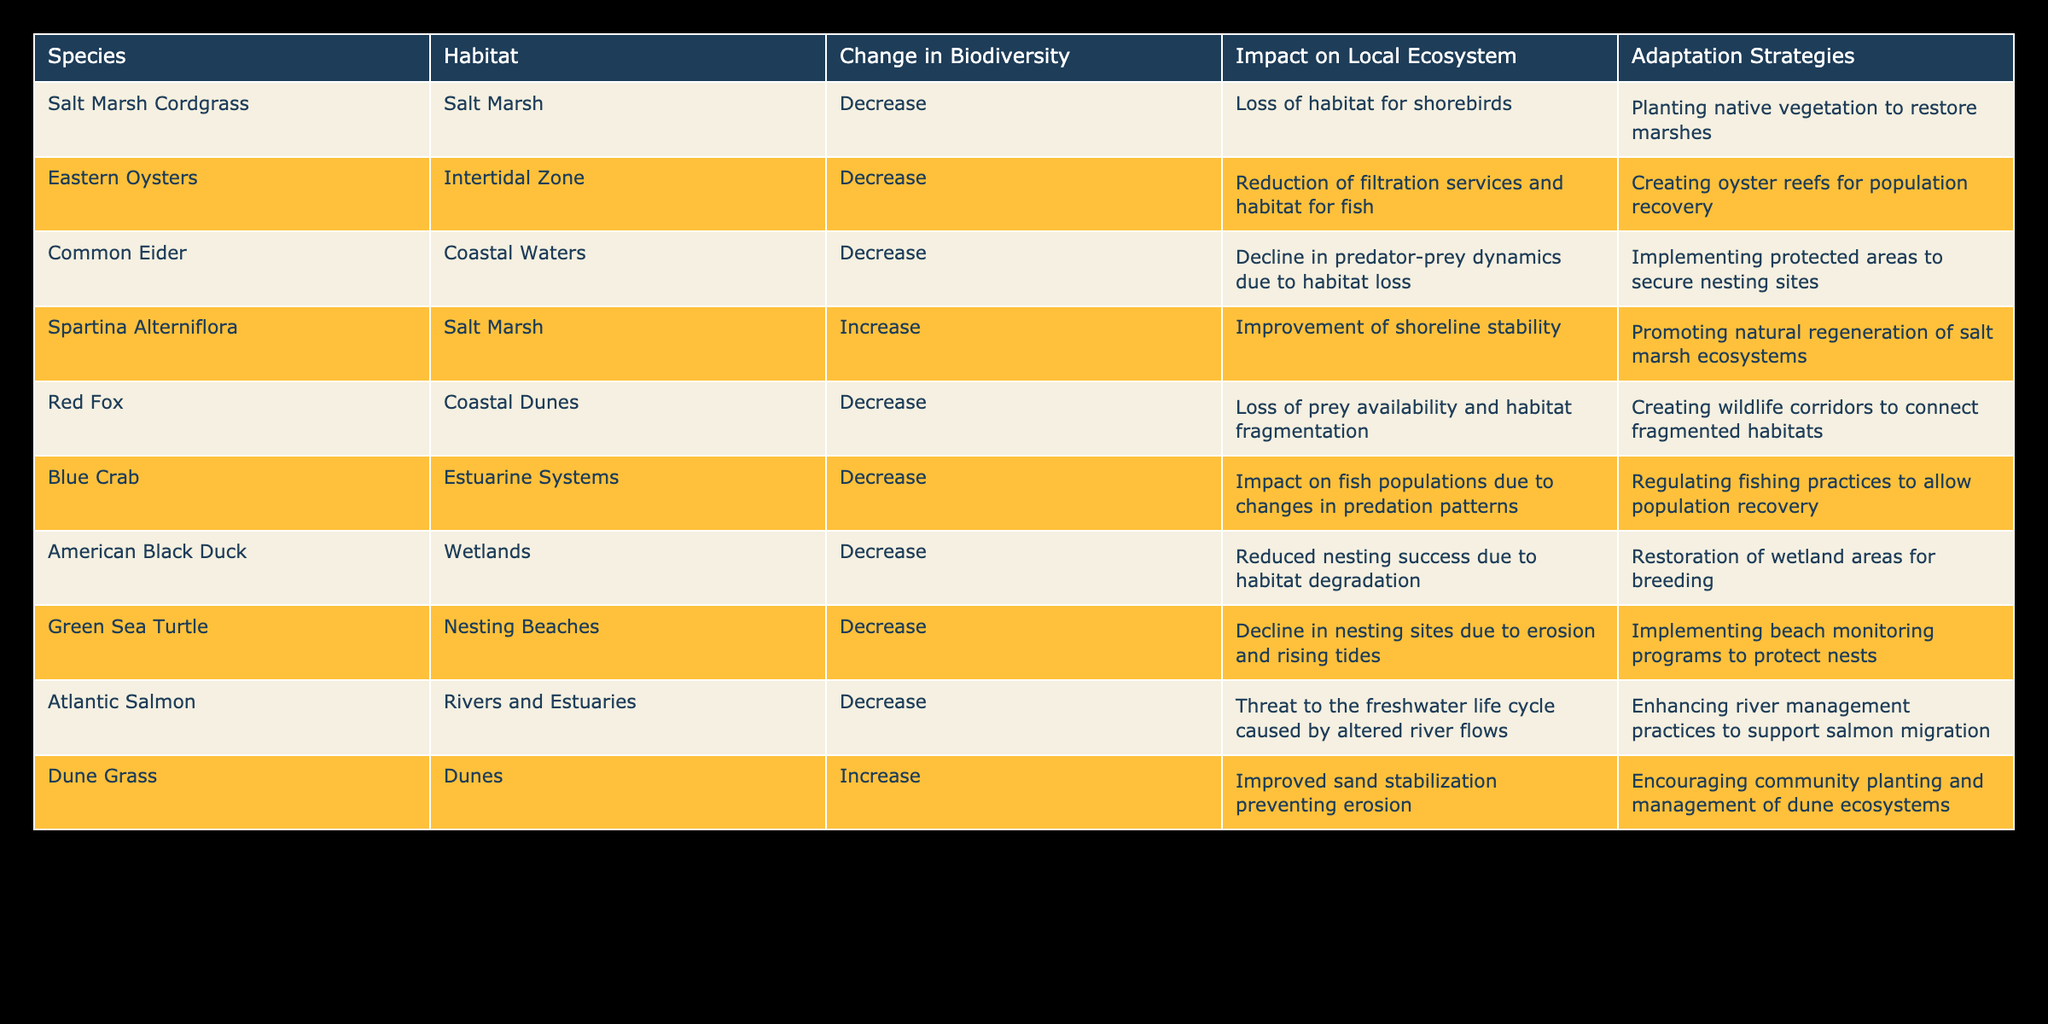What is the impact on shorebirds due to changes in Salt Marsh Cordgrass? According to the table, the Salt Marsh Cordgrass has a decrease in biodiversity which results in the loss of habitat for shorebirds.
Answer: Loss of habitat for shorebirds How many species have seen an increase in biodiversity? The table lists two species (Spartina Alterniflora and Dune Grass) that have experienced an increase in biodiversity.
Answer: 2 Is there a decrease in biodiversity for the Eastern Oysters? Yes, the table indicates that Eastern Oysters have a decrease in biodiversity.
Answer: Yes What are the adaptation strategies suggested for American Black Duck? The table states that the adaptation strategy for American Black Duck is the restoration of wetland areas for breeding.
Answer: Restoration of wetland areas for breeding How does the decrease in Blue Crabs affect fish populations? The Blue Crab has a decrease in biodiversity impacting fish populations due to changes in predation patterns. This suggests that as Blue Crab numbers decrease, there may be fewer predators leading to a potential overpopulation of their prey.
Answer: Changes in predation patterns affect fish populations What is the total number of species that impact local ecosystems due to decreased biodiversity? The table shows that there are seven species (Salt Marsh Cordgrass, Eastern Oysters, Common Eider, Red Fox, Blue Crab, American Black Duck, Green Sea Turtle, Atlantic Salmon) that have a decrease in biodiversity affecting local ecosystems. Counting these species gives us a total of seven.
Answer: 7 What habitat does Spartina Alterniflora improve, and how? Spartina Alterniflora is located in Salt Marsh and improves shoreline stability, enhancing coastal resilience against erosion.
Answer: Shoreline stability improvement Does the decline in Green Sea Turtle nesting sites contribute to a decrease in biodiversity? Yes, the decline in nesting sites for Green Sea Turtles due to erosion and rising tides is recorded as a decrease, thus contributing to biodiversity decline.
Answer: Yes What adaptation strategy is implemented for enhancing river management for Atlantic Salmon? The adaptation strategy mentioned for Atlantic Salmon includes enhancing river management practices to support their migration.
Answer: Enhancing river management practices for migration 